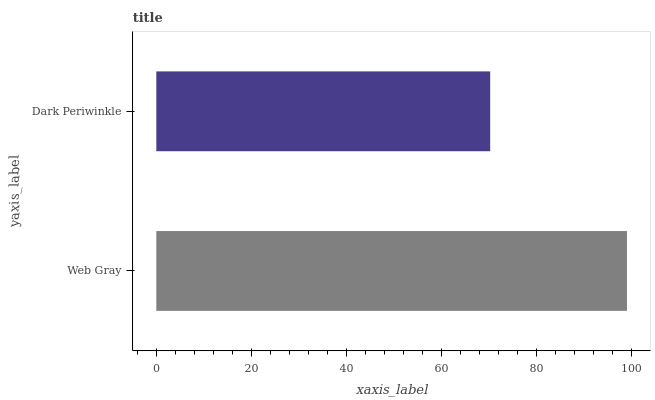Is Dark Periwinkle the minimum?
Answer yes or no. Yes. Is Web Gray the maximum?
Answer yes or no. Yes. Is Dark Periwinkle the maximum?
Answer yes or no. No. Is Web Gray greater than Dark Periwinkle?
Answer yes or no. Yes. Is Dark Periwinkle less than Web Gray?
Answer yes or no. Yes. Is Dark Periwinkle greater than Web Gray?
Answer yes or no. No. Is Web Gray less than Dark Periwinkle?
Answer yes or no. No. Is Web Gray the high median?
Answer yes or no. Yes. Is Dark Periwinkle the low median?
Answer yes or no. Yes. Is Dark Periwinkle the high median?
Answer yes or no. No. Is Web Gray the low median?
Answer yes or no. No. 